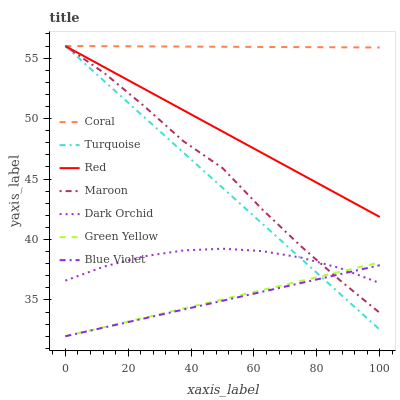Does Blue Violet have the minimum area under the curve?
Answer yes or no. Yes. Does Coral have the maximum area under the curve?
Answer yes or no. Yes. Does Dark Orchid have the minimum area under the curve?
Answer yes or no. No. Does Dark Orchid have the maximum area under the curve?
Answer yes or no. No. Is Blue Violet the smoothest?
Answer yes or no. Yes. Is Maroon the roughest?
Answer yes or no. Yes. Is Coral the smoothest?
Answer yes or no. No. Is Coral the roughest?
Answer yes or no. No. Does Dark Orchid have the lowest value?
Answer yes or no. No. Does Dark Orchid have the highest value?
Answer yes or no. No. Is Green Yellow less than Coral?
Answer yes or no. Yes. Is Coral greater than Blue Violet?
Answer yes or no. Yes. Does Green Yellow intersect Coral?
Answer yes or no. No. 